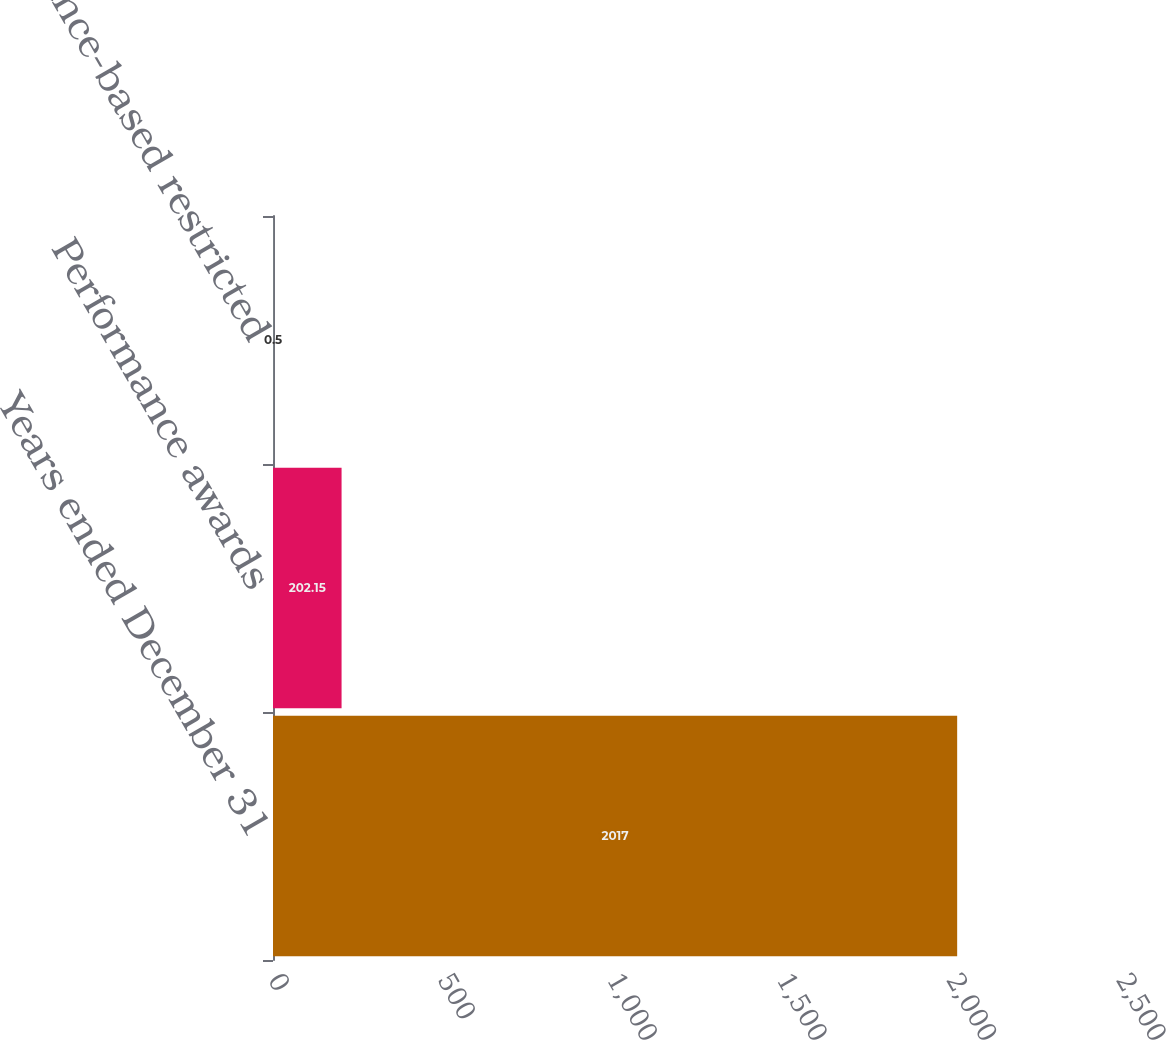Convert chart. <chart><loc_0><loc_0><loc_500><loc_500><bar_chart><fcel>Years ended December 31<fcel>Performance awards<fcel>Performance-based restricted<nl><fcel>2017<fcel>202.15<fcel>0.5<nl></chart> 